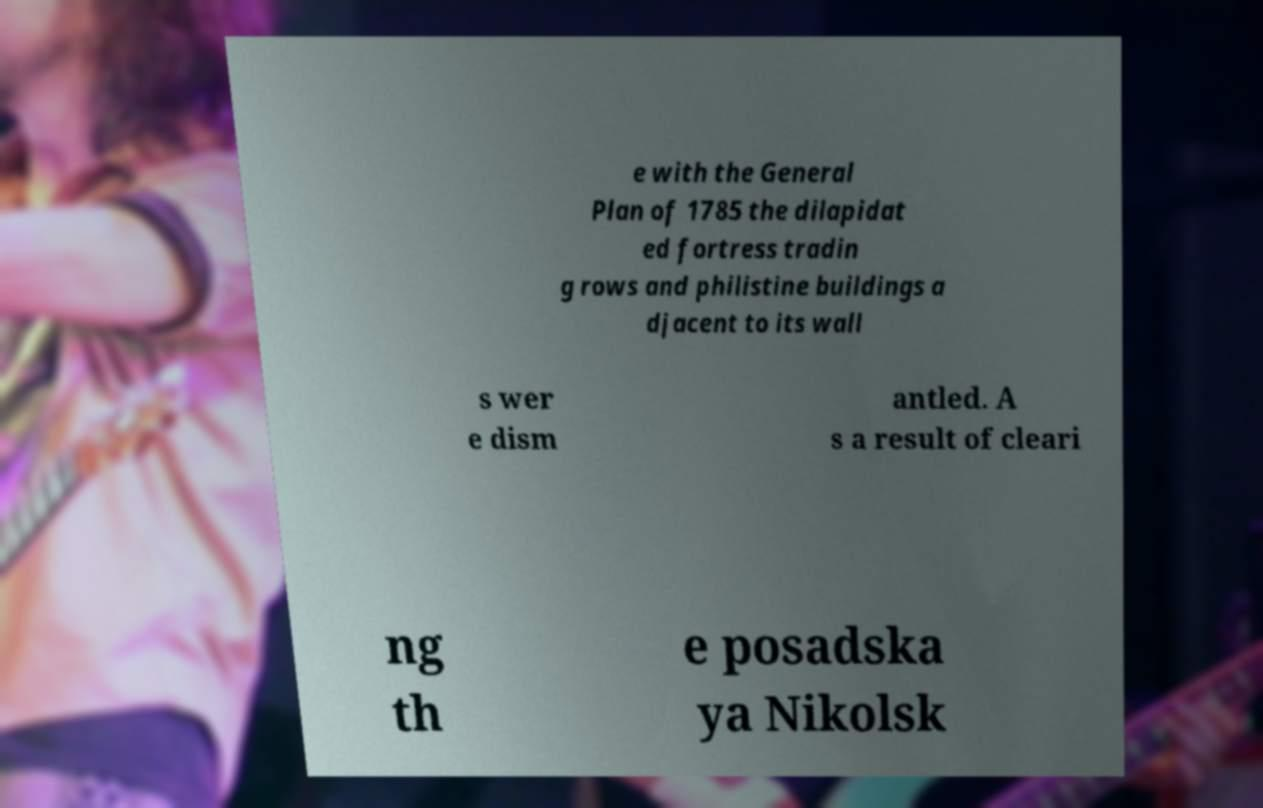I need the written content from this picture converted into text. Can you do that? e with the General Plan of 1785 the dilapidat ed fortress tradin g rows and philistine buildings a djacent to its wall s wer e dism antled. A s a result of cleari ng th e posadska ya Nikolsk 